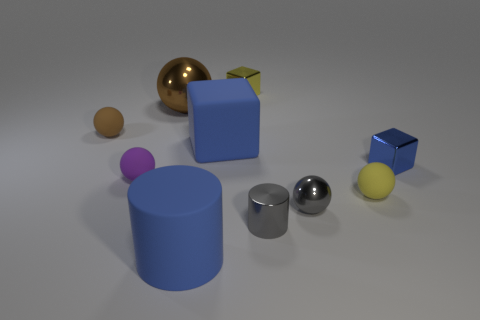Subtract all blue cylinders. How many brown balls are left? 2 Subtract all small brown matte balls. How many balls are left? 4 Subtract all gray balls. How many balls are left? 4 Subtract 1 blocks. How many blocks are left? 2 Subtract all blocks. How many objects are left? 7 Subtract all yellow matte spheres. Subtract all rubber spheres. How many objects are left? 6 Add 3 large blue matte objects. How many large blue matte objects are left? 5 Add 4 big shiny cylinders. How many big shiny cylinders exist? 4 Subtract 0 red blocks. How many objects are left? 10 Subtract all green spheres. Subtract all red cylinders. How many spheres are left? 5 